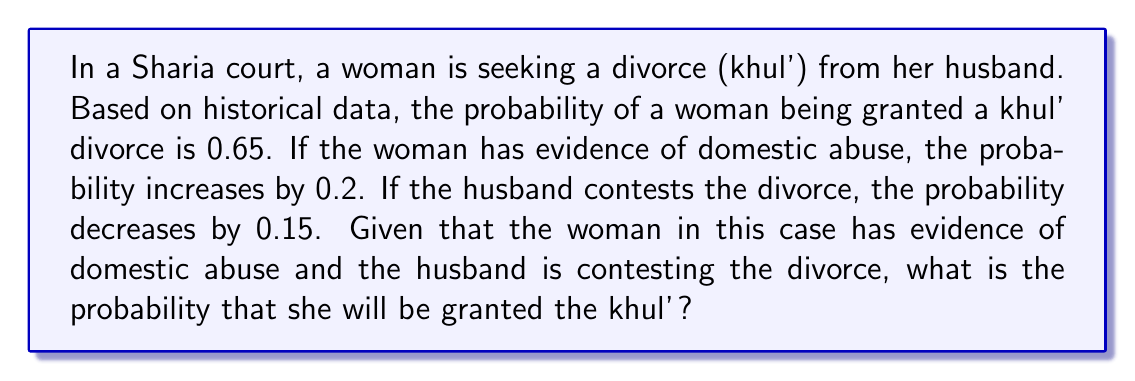Can you solve this math problem? To solve this problem, we need to apply the concept of conditional probability and the given information. Let's break it down step by step:

1. The base probability of a woman being granted a khul' divorce:
   $P(\text{khul'}) = 0.65$

2. The increase in probability due to evidence of domestic abuse:
   $P(\text{khul'|abuse}) = P(\text{khul'}) + 0.2 = 0.65 + 0.2 = 0.85$

3. The decrease in probability due to the husband contesting the divorce:
   $P(\text{khul'|contest}) = P(\text{khul'}) - 0.15 = 0.65 - 0.15 = 0.50$

4. In this case, we have both factors present: evidence of abuse and husband contesting. We need to combine these effects:

   $P(\text{khul'|abuse, contest}) = P(\text{khul'}) + 0.2 - 0.15 = 0.65 + 0.2 - 0.15 = 0.70$

Therefore, the probability of the woman being granted a khul' divorce under these circumstances is 0.70 or 70%.

It's important to note that this calculation assumes the effects are additive and independent. In a real-world scenario, the interaction between these factors might be more complex, and a more sophisticated statistical model might be required for a more accurate prediction.
Answer: The probability that the woman will be granted the khul' divorce is $0.70$ or $70\%$. 